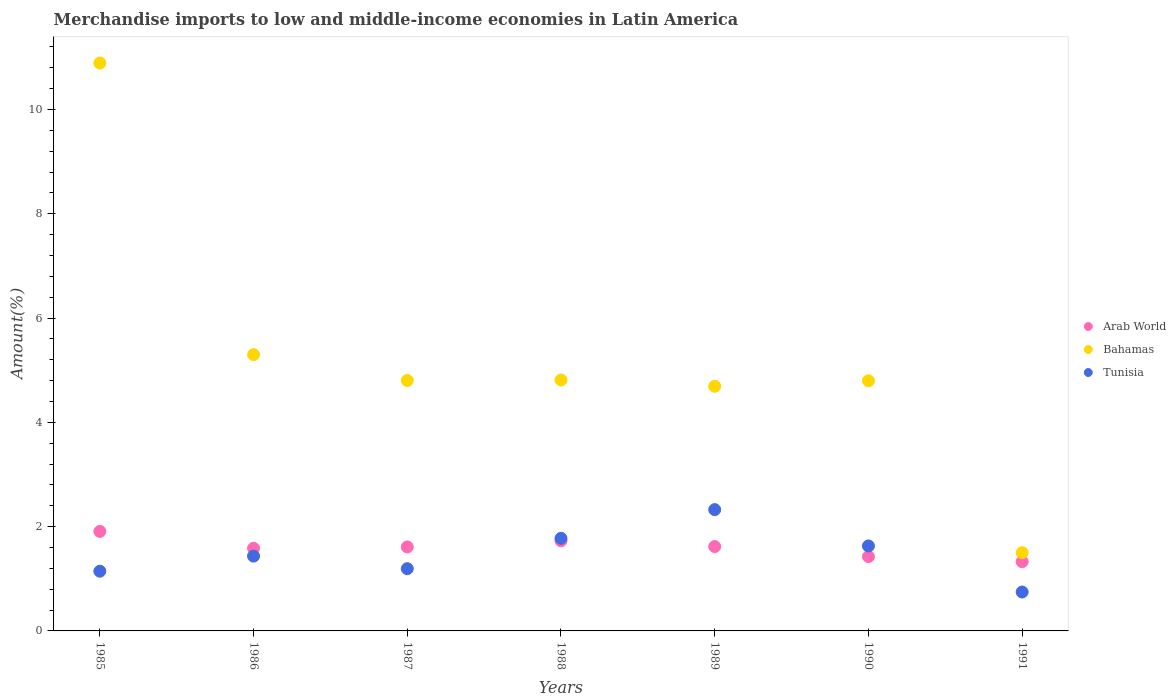Is the number of dotlines equal to the number of legend labels?
Your answer should be very brief. Yes. What is the percentage of amount earned from merchandise imports in Bahamas in 1988?
Your answer should be very brief. 4.81. Across all years, what is the maximum percentage of amount earned from merchandise imports in Bahamas?
Make the answer very short. 10.89. Across all years, what is the minimum percentage of amount earned from merchandise imports in Bahamas?
Provide a succinct answer. 1.5. In which year was the percentage of amount earned from merchandise imports in Arab World maximum?
Ensure brevity in your answer.  1985. In which year was the percentage of amount earned from merchandise imports in Arab World minimum?
Make the answer very short. 1991. What is the total percentage of amount earned from merchandise imports in Arab World in the graph?
Ensure brevity in your answer.  11.2. What is the difference between the percentage of amount earned from merchandise imports in Tunisia in 1985 and that in 1989?
Give a very brief answer. -1.18. What is the difference between the percentage of amount earned from merchandise imports in Tunisia in 1991 and the percentage of amount earned from merchandise imports in Arab World in 1987?
Provide a short and direct response. -0.86. What is the average percentage of amount earned from merchandise imports in Bahamas per year?
Your response must be concise. 5.26. In the year 1991, what is the difference between the percentage of amount earned from merchandise imports in Arab World and percentage of amount earned from merchandise imports in Tunisia?
Give a very brief answer. 0.58. What is the ratio of the percentage of amount earned from merchandise imports in Arab World in 1985 to that in 1990?
Offer a very short reply. 1.34. Is the percentage of amount earned from merchandise imports in Bahamas in 1988 less than that in 1991?
Your answer should be very brief. No. Is the difference between the percentage of amount earned from merchandise imports in Arab World in 1987 and 1989 greater than the difference between the percentage of amount earned from merchandise imports in Tunisia in 1987 and 1989?
Keep it short and to the point. Yes. What is the difference between the highest and the second highest percentage of amount earned from merchandise imports in Tunisia?
Your answer should be very brief. 0.55. What is the difference between the highest and the lowest percentage of amount earned from merchandise imports in Bahamas?
Provide a short and direct response. 9.39. Is the sum of the percentage of amount earned from merchandise imports in Bahamas in 1985 and 1991 greater than the maximum percentage of amount earned from merchandise imports in Tunisia across all years?
Provide a short and direct response. Yes. Is it the case that in every year, the sum of the percentage of amount earned from merchandise imports in Tunisia and percentage of amount earned from merchandise imports in Arab World  is greater than the percentage of amount earned from merchandise imports in Bahamas?
Give a very brief answer. No. Does the percentage of amount earned from merchandise imports in Arab World monotonically increase over the years?
Your response must be concise. No. How many years are there in the graph?
Give a very brief answer. 7. Are the values on the major ticks of Y-axis written in scientific E-notation?
Your answer should be compact. No. Does the graph contain grids?
Your answer should be very brief. No. Where does the legend appear in the graph?
Your answer should be very brief. Center right. How many legend labels are there?
Provide a short and direct response. 3. What is the title of the graph?
Your response must be concise. Merchandise imports to low and middle-income economies in Latin America. What is the label or title of the Y-axis?
Your answer should be very brief. Amount(%). What is the Amount(%) in Arab World in 1985?
Your answer should be very brief. 1.91. What is the Amount(%) of Bahamas in 1985?
Offer a very short reply. 10.89. What is the Amount(%) in Tunisia in 1985?
Ensure brevity in your answer.  1.15. What is the Amount(%) of Arab World in 1986?
Keep it short and to the point. 1.58. What is the Amount(%) of Bahamas in 1986?
Your response must be concise. 5.3. What is the Amount(%) of Tunisia in 1986?
Keep it short and to the point. 1.43. What is the Amount(%) of Arab World in 1987?
Ensure brevity in your answer.  1.61. What is the Amount(%) in Bahamas in 1987?
Offer a very short reply. 4.8. What is the Amount(%) in Tunisia in 1987?
Give a very brief answer. 1.19. What is the Amount(%) in Arab World in 1988?
Provide a short and direct response. 1.73. What is the Amount(%) of Bahamas in 1988?
Your answer should be compact. 4.81. What is the Amount(%) in Tunisia in 1988?
Ensure brevity in your answer.  1.78. What is the Amount(%) in Arab World in 1989?
Make the answer very short. 1.62. What is the Amount(%) in Bahamas in 1989?
Give a very brief answer. 4.69. What is the Amount(%) of Tunisia in 1989?
Your answer should be compact. 2.33. What is the Amount(%) in Arab World in 1990?
Offer a very short reply. 1.43. What is the Amount(%) of Bahamas in 1990?
Offer a terse response. 4.8. What is the Amount(%) of Tunisia in 1990?
Offer a terse response. 1.63. What is the Amount(%) of Arab World in 1991?
Keep it short and to the point. 1.33. What is the Amount(%) of Bahamas in 1991?
Ensure brevity in your answer.  1.5. What is the Amount(%) of Tunisia in 1991?
Offer a terse response. 0.75. Across all years, what is the maximum Amount(%) in Arab World?
Offer a very short reply. 1.91. Across all years, what is the maximum Amount(%) of Bahamas?
Offer a very short reply. 10.89. Across all years, what is the maximum Amount(%) of Tunisia?
Keep it short and to the point. 2.33. Across all years, what is the minimum Amount(%) in Arab World?
Provide a short and direct response. 1.33. Across all years, what is the minimum Amount(%) in Bahamas?
Ensure brevity in your answer.  1.5. Across all years, what is the minimum Amount(%) in Tunisia?
Offer a terse response. 0.75. What is the total Amount(%) of Arab World in the graph?
Your answer should be very brief. 11.2. What is the total Amount(%) of Bahamas in the graph?
Provide a succinct answer. 36.79. What is the total Amount(%) in Tunisia in the graph?
Your answer should be very brief. 10.25. What is the difference between the Amount(%) of Arab World in 1985 and that in 1986?
Provide a short and direct response. 0.32. What is the difference between the Amount(%) in Bahamas in 1985 and that in 1986?
Offer a terse response. 5.59. What is the difference between the Amount(%) in Tunisia in 1985 and that in 1986?
Provide a succinct answer. -0.29. What is the difference between the Amount(%) of Arab World in 1985 and that in 1987?
Offer a very short reply. 0.3. What is the difference between the Amount(%) of Bahamas in 1985 and that in 1987?
Provide a succinct answer. 6.09. What is the difference between the Amount(%) in Tunisia in 1985 and that in 1987?
Provide a succinct answer. -0.05. What is the difference between the Amount(%) of Arab World in 1985 and that in 1988?
Your response must be concise. 0.18. What is the difference between the Amount(%) of Bahamas in 1985 and that in 1988?
Keep it short and to the point. 6.08. What is the difference between the Amount(%) of Tunisia in 1985 and that in 1988?
Offer a terse response. -0.63. What is the difference between the Amount(%) of Arab World in 1985 and that in 1989?
Offer a terse response. 0.29. What is the difference between the Amount(%) of Bahamas in 1985 and that in 1989?
Your answer should be compact. 6.2. What is the difference between the Amount(%) of Tunisia in 1985 and that in 1989?
Give a very brief answer. -1.18. What is the difference between the Amount(%) in Arab World in 1985 and that in 1990?
Your response must be concise. 0.48. What is the difference between the Amount(%) of Bahamas in 1985 and that in 1990?
Give a very brief answer. 6.09. What is the difference between the Amount(%) in Tunisia in 1985 and that in 1990?
Your answer should be very brief. -0.48. What is the difference between the Amount(%) in Arab World in 1985 and that in 1991?
Ensure brevity in your answer.  0.58. What is the difference between the Amount(%) of Bahamas in 1985 and that in 1991?
Your answer should be very brief. 9.39. What is the difference between the Amount(%) in Tunisia in 1985 and that in 1991?
Your response must be concise. 0.4. What is the difference between the Amount(%) of Arab World in 1986 and that in 1987?
Make the answer very short. -0.03. What is the difference between the Amount(%) in Bahamas in 1986 and that in 1987?
Offer a terse response. 0.5. What is the difference between the Amount(%) in Tunisia in 1986 and that in 1987?
Give a very brief answer. 0.24. What is the difference between the Amount(%) in Arab World in 1986 and that in 1988?
Give a very brief answer. -0.14. What is the difference between the Amount(%) of Bahamas in 1986 and that in 1988?
Your answer should be compact. 0.49. What is the difference between the Amount(%) in Tunisia in 1986 and that in 1988?
Give a very brief answer. -0.34. What is the difference between the Amount(%) of Arab World in 1986 and that in 1989?
Make the answer very short. -0.03. What is the difference between the Amount(%) in Bahamas in 1986 and that in 1989?
Provide a succinct answer. 0.61. What is the difference between the Amount(%) in Tunisia in 1986 and that in 1989?
Your answer should be very brief. -0.89. What is the difference between the Amount(%) in Arab World in 1986 and that in 1990?
Make the answer very short. 0.16. What is the difference between the Amount(%) of Bahamas in 1986 and that in 1990?
Your response must be concise. 0.5. What is the difference between the Amount(%) in Tunisia in 1986 and that in 1990?
Ensure brevity in your answer.  -0.19. What is the difference between the Amount(%) of Arab World in 1986 and that in 1991?
Your answer should be very brief. 0.26. What is the difference between the Amount(%) in Bahamas in 1986 and that in 1991?
Provide a short and direct response. 3.8. What is the difference between the Amount(%) of Tunisia in 1986 and that in 1991?
Offer a terse response. 0.69. What is the difference between the Amount(%) in Arab World in 1987 and that in 1988?
Give a very brief answer. -0.12. What is the difference between the Amount(%) in Bahamas in 1987 and that in 1988?
Your answer should be compact. -0.01. What is the difference between the Amount(%) in Tunisia in 1987 and that in 1988?
Your answer should be compact. -0.58. What is the difference between the Amount(%) in Arab World in 1987 and that in 1989?
Provide a short and direct response. -0.01. What is the difference between the Amount(%) in Tunisia in 1987 and that in 1989?
Your answer should be compact. -1.13. What is the difference between the Amount(%) in Arab World in 1987 and that in 1990?
Offer a terse response. 0.18. What is the difference between the Amount(%) of Bahamas in 1987 and that in 1990?
Ensure brevity in your answer.  0.01. What is the difference between the Amount(%) of Tunisia in 1987 and that in 1990?
Give a very brief answer. -0.44. What is the difference between the Amount(%) of Arab World in 1987 and that in 1991?
Your answer should be compact. 0.28. What is the difference between the Amount(%) of Bahamas in 1987 and that in 1991?
Give a very brief answer. 3.3. What is the difference between the Amount(%) in Tunisia in 1987 and that in 1991?
Provide a succinct answer. 0.45. What is the difference between the Amount(%) of Arab World in 1988 and that in 1989?
Provide a succinct answer. 0.11. What is the difference between the Amount(%) of Bahamas in 1988 and that in 1989?
Keep it short and to the point. 0.12. What is the difference between the Amount(%) of Tunisia in 1988 and that in 1989?
Provide a short and direct response. -0.55. What is the difference between the Amount(%) of Arab World in 1988 and that in 1990?
Offer a terse response. 0.3. What is the difference between the Amount(%) in Bahamas in 1988 and that in 1990?
Provide a short and direct response. 0.02. What is the difference between the Amount(%) of Tunisia in 1988 and that in 1990?
Make the answer very short. 0.15. What is the difference between the Amount(%) of Arab World in 1988 and that in 1991?
Offer a very short reply. 0.4. What is the difference between the Amount(%) of Bahamas in 1988 and that in 1991?
Offer a very short reply. 3.31. What is the difference between the Amount(%) of Tunisia in 1988 and that in 1991?
Your answer should be very brief. 1.03. What is the difference between the Amount(%) of Arab World in 1989 and that in 1990?
Your response must be concise. 0.19. What is the difference between the Amount(%) of Bahamas in 1989 and that in 1990?
Ensure brevity in your answer.  -0.11. What is the difference between the Amount(%) in Tunisia in 1989 and that in 1990?
Ensure brevity in your answer.  0.7. What is the difference between the Amount(%) in Arab World in 1989 and that in 1991?
Your answer should be very brief. 0.29. What is the difference between the Amount(%) in Bahamas in 1989 and that in 1991?
Keep it short and to the point. 3.19. What is the difference between the Amount(%) of Tunisia in 1989 and that in 1991?
Offer a very short reply. 1.58. What is the difference between the Amount(%) of Arab World in 1990 and that in 1991?
Your answer should be very brief. 0.1. What is the difference between the Amount(%) of Bahamas in 1990 and that in 1991?
Offer a terse response. 3.3. What is the difference between the Amount(%) in Tunisia in 1990 and that in 1991?
Offer a very short reply. 0.88. What is the difference between the Amount(%) of Arab World in 1985 and the Amount(%) of Bahamas in 1986?
Provide a short and direct response. -3.39. What is the difference between the Amount(%) in Arab World in 1985 and the Amount(%) in Tunisia in 1986?
Provide a short and direct response. 0.47. What is the difference between the Amount(%) in Bahamas in 1985 and the Amount(%) in Tunisia in 1986?
Your response must be concise. 9.46. What is the difference between the Amount(%) in Arab World in 1985 and the Amount(%) in Bahamas in 1987?
Provide a short and direct response. -2.89. What is the difference between the Amount(%) in Arab World in 1985 and the Amount(%) in Tunisia in 1987?
Offer a terse response. 0.71. What is the difference between the Amount(%) in Bahamas in 1985 and the Amount(%) in Tunisia in 1987?
Your answer should be very brief. 9.7. What is the difference between the Amount(%) of Arab World in 1985 and the Amount(%) of Bahamas in 1988?
Offer a very short reply. -2.9. What is the difference between the Amount(%) in Arab World in 1985 and the Amount(%) in Tunisia in 1988?
Make the answer very short. 0.13. What is the difference between the Amount(%) in Bahamas in 1985 and the Amount(%) in Tunisia in 1988?
Give a very brief answer. 9.11. What is the difference between the Amount(%) in Arab World in 1985 and the Amount(%) in Bahamas in 1989?
Offer a very short reply. -2.78. What is the difference between the Amount(%) in Arab World in 1985 and the Amount(%) in Tunisia in 1989?
Keep it short and to the point. -0.42. What is the difference between the Amount(%) of Bahamas in 1985 and the Amount(%) of Tunisia in 1989?
Give a very brief answer. 8.56. What is the difference between the Amount(%) in Arab World in 1985 and the Amount(%) in Bahamas in 1990?
Your answer should be very brief. -2.89. What is the difference between the Amount(%) of Arab World in 1985 and the Amount(%) of Tunisia in 1990?
Make the answer very short. 0.28. What is the difference between the Amount(%) of Bahamas in 1985 and the Amount(%) of Tunisia in 1990?
Make the answer very short. 9.26. What is the difference between the Amount(%) in Arab World in 1985 and the Amount(%) in Bahamas in 1991?
Provide a short and direct response. 0.41. What is the difference between the Amount(%) of Arab World in 1985 and the Amount(%) of Tunisia in 1991?
Your answer should be compact. 1.16. What is the difference between the Amount(%) in Bahamas in 1985 and the Amount(%) in Tunisia in 1991?
Your answer should be compact. 10.14. What is the difference between the Amount(%) of Arab World in 1986 and the Amount(%) of Bahamas in 1987?
Keep it short and to the point. -3.22. What is the difference between the Amount(%) of Arab World in 1986 and the Amount(%) of Tunisia in 1987?
Make the answer very short. 0.39. What is the difference between the Amount(%) of Bahamas in 1986 and the Amount(%) of Tunisia in 1987?
Your response must be concise. 4.1. What is the difference between the Amount(%) in Arab World in 1986 and the Amount(%) in Bahamas in 1988?
Offer a terse response. -3.23. What is the difference between the Amount(%) in Arab World in 1986 and the Amount(%) in Tunisia in 1988?
Keep it short and to the point. -0.19. What is the difference between the Amount(%) of Bahamas in 1986 and the Amount(%) of Tunisia in 1988?
Offer a very short reply. 3.52. What is the difference between the Amount(%) in Arab World in 1986 and the Amount(%) in Bahamas in 1989?
Your answer should be very brief. -3.11. What is the difference between the Amount(%) in Arab World in 1986 and the Amount(%) in Tunisia in 1989?
Ensure brevity in your answer.  -0.74. What is the difference between the Amount(%) in Bahamas in 1986 and the Amount(%) in Tunisia in 1989?
Provide a succinct answer. 2.97. What is the difference between the Amount(%) in Arab World in 1986 and the Amount(%) in Bahamas in 1990?
Offer a very short reply. -3.21. What is the difference between the Amount(%) in Arab World in 1986 and the Amount(%) in Tunisia in 1990?
Ensure brevity in your answer.  -0.04. What is the difference between the Amount(%) of Bahamas in 1986 and the Amount(%) of Tunisia in 1990?
Provide a succinct answer. 3.67. What is the difference between the Amount(%) of Arab World in 1986 and the Amount(%) of Bahamas in 1991?
Your response must be concise. 0.08. What is the difference between the Amount(%) in Arab World in 1986 and the Amount(%) in Tunisia in 1991?
Provide a succinct answer. 0.84. What is the difference between the Amount(%) in Bahamas in 1986 and the Amount(%) in Tunisia in 1991?
Your answer should be compact. 4.55. What is the difference between the Amount(%) of Arab World in 1987 and the Amount(%) of Bahamas in 1988?
Offer a terse response. -3.2. What is the difference between the Amount(%) of Arab World in 1987 and the Amount(%) of Tunisia in 1988?
Offer a very short reply. -0.16. What is the difference between the Amount(%) of Bahamas in 1987 and the Amount(%) of Tunisia in 1988?
Keep it short and to the point. 3.03. What is the difference between the Amount(%) in Arab World in 1987 and the Amount(%) in Bahamas in 1989?
Your response must be concise. -3.08. What is the difference between the Amount(%) of Arab World in 1987 and the Amount(%) of Tunisia in 1989?
Your answer should be compact. -0.72. What is the difference between the Amount(%) in Bahamas in 1987 and the Amount(%) in Tunisia in 1989?
Your answer should be very brief. 2.48. What is the difference between the Amount(%) of Arab World in 1987 and the Amount(%) of Bahamas in 1990?
Your answer should be very brief. -3.19. What is the difference between the Amount(%) in Arab World in 1987 and the Amount(%) in Tunisia in 1990?
Your response must be concise. -0.02. What is the difference between the Amount(%) in Bahamas in 1987 and the Amount(%) in Tunisia in 1990?
Provide a succinct answer. 3.17. What is the difference between the Amount(%) in Arab World in 1987 and the Amount(%) in Bahamas in 1991?
Offer a very short reply. 0.11. What is the difference between the Amount(%) in Arab World in 1987 and the Amount(%) in Tunisia in 1991?
Your answer should be compact. 0.86. What is the difference between the Amount(%) of Bahamas in 1987 and the Amount(%) of Tunisia in 1991?
Provide a succinct answer. 4.06. What is the difference between the Amount(%) in Arab World in 1988 and the Amount(%) in Bahamas in 1989?
Your answer should be very brief. -2.96. What is the difference between the Amount(%) in Arab World in 1988 and the Amount(%) in Tunisia in 1989?
Your answer should be compact. -0.6. What is the difference between the Amount(%) in Bahamas in 1988 and the Amount(%) in Tunisia in 1989?
Offer a terse response. 2.49. What is the difference between the Amount(%) in Arab World in 1988 and the Amount(%) in Bahamas in 1990?
Provide a succinct answer. -3.07. What is the difference between the Amount(%) of Arab World in 1988 and the Amount(%) of Tunisia in 1990?
Your answer should be compact. 0.1. What is the difference between the Amount(%) in Bahamas in 1988 and the Amount(%) in Tunisia in 1990?
Keep it short and to the point. 3.18. What is the difference between the Amount(%) of Arab World in 1988 and the Amount(%) of Bahamas in 1991?
Give a very brief answer. 0.23. What is the difference between the Amount(%) in Arab World in 1988 and the Amount(%) in Tunisia in 1991?
Offer a terse response. 0.98. What is the difference between the Amount(%) in Bahamas in 1988 and the Amount(%) in Tunisia in 1991?
Offer a terse response. 4.07. What is the difference between the Amount(%) in Arab World in 1989 and the Amount(%) in Bahamas in 1990?
Provide a short and direct response. -3.18. What is the difference between the Amount(%) of Arab World in 1989 and the Amount(%) of Tunisia in 1990?
Provide a succinct answer. -0.01. What is the difference between the Amount(%) in Bahamas in 1989 and the Amount(%) in Tunisia in 1990?
Your answer should be compact. 3.06. What is the difference between the Amount(%) in Arab World in 1989 and the Amount(%) in Bahamas in 1991?
Offer a terse response. 0.12. What is the difference between the Amount(%) of Arab World in 1989 and the Amount(%) of Tunisia in 1991?
Provide a succinct answer. 0.87. What is the difference between the Amount(%) of Bahamas in 1989 and the Amount(%) of Tunisia in 1991?
Your answer should be compact. 3.95. What is the difference between the Amount(%) of Arab World in 1990 and the Amount(%) of Bahamas in 1991?
Provide a short and direct response. -0.07. What is the difference between the Amount(%) of Arab World in 1990 and the Amount(%) of Tunisia in 1991?
Provide a short and direct response. 0.68. What is the difference between the Amount(%) in Bahamas in 1990 and the Amount(%) in Tunisia in 1991?
Give a very brief answer. 4.05. What is the average Amount(%) in Arab World per year?
Keep it short and to the point. 1.6. What is the average Amount(%) of Bahamas per year?
Provide a succinct answer. 5.26. What is the average Amount(%) in Tunisia per year?
Your response must be concise. 1.46. In the year 1985, what is the difference between the Amount(%) in Arab World and Amount(%) in Bahamas?
Your response must be concise. -8.98. In the year 1985, what is the difference between the Amount(%) in Arab World and Amount(%) in Tunisia?
Your response must be concise. 0.76. In the year 1985, what is the difference between the Amount(%) of Bahamas and Amount(%) of Tunisia?
Keep it short and to the point. 9.75. In the year 1986, what is the difference between the Amount(%) in Arab World and Amount(%) in Bahamas?
Your answer should be compact. -3.71. In the year 1986, what is the difference between the Amount(%) of Arab World and Amount(%) of Tunisia?
Offer a terse response. 0.15. In the year 1986, what is the difference between the Amount(%) of Bahamas and Amount(%) of Tunisia?
Provide a short and direct response. 3.86. In the year 1987, what is the difference between the Amount(%) of Arab World and Amount(%) of Bahamas?
Your answer should be compact. -3.19. In the year 1987, what is the difference between the Amount(%) in Arab World and Amount(%) in Tunisia?
Ensure brevity in your answer.  0.42. In the year 1987, what is the difference between the Amount(%) in Bahamas and Amount(%) in Tunisia?
Your response must be concise. 3.61. In the year 1988, what is the difference between the Amount(%) of Arab World and Amount(%) of Bahamas?
Give a very brief answer. -3.09. In the year 1988, what is the difference between the Amount(%) in Arab World and Amount(%) in Tunisia?
Your response must be concise. -0.05. In the year 1988, what is the difference between the Amount(%) of Bahamas and Amount(%) of Tunisia?
Provide a succinct answer. 3.04. In the year 1989, what is the difference between the Amount(%) of Arab World and Amount(%) of Bahamas?
Provide a succinct answer. -3.07. In the year 1989, what is the difference between the Amount(%) in Arab World and Amount(%) in Tunisia?
Offer a very short reply. -0.71. In the year 1989, what is the difference between the Amount(%) in Bahamas and Amount(%) in Tunisia?
Offer a very short reply. 2.37. In the year 1990, what is the difference between the Amount(%) of Arab World and Amount(%) of Bahamas?
Ensure brevity in your answer.  -3.37. In the year 1990, what is the difference between the Amount(%) of Arab World and Amount(%) of Tunisia?
Offer a terse response. -0.2. In the year 1990, what is the difference between the Amount(%) in Bahamas and Amount(%) in Tunisia?
Provide a short and direct response. 3.17. In the year 1991, what is the difference between the Amount(%) of Arab World and Amount(%) of Bahamas?
Provide a short and direct response. -0.17. In the year 1991, what is the difference between the Amount(%) in Arab World and Amount(%) in Tunisia?
Offer a very short reply. 0.58. In the year 1991, what is the difference between the Amount(%) of Bahamas and Amount(%) of Tunisia?
Offer a very short reply. 0.75. What is the ratio of the Amount(%) of Arab World in 1985 to that in 1986?
Provide a short and direct response. 1.2. What is the ratio of the Amount(%) of Bahamas in 1985 to that in 1986?
Provide a short and direct response. 2.06. What is the ratio of the Amount(%) of Tunisia in 1985 to that in 1986?
Keep it short and to the point. 0.8. What is the ratio of the Amount(%) in Arab World in 1985 to that in 1987?
Make the answer very short. 1.18. What is the ratio of the Amount(%) in Bahamas in 1985 to that in 1987?
Your answer should be very brief. 2.27. What is the ratio of the Amount(%) of Tunisia in 1985 to that in 1987?
Give a very brief answer. 0.96. What is the ratio of the Amount(%) in Arab World in 1985 to that in 1988?
Provide a succinct answer. 1.11. What is the ratio of the Amount(%) in Bahamas in 1985 to that in 1988?
Provide a succinct answer. 2.26. What is the ratio of the Amount(%) in Tunisia in 1985 to that in 1988?
Offer a very short reply. 0.65. What is the ratio of the Amount(%) in Arab World in 1985 to that in 1989?
Make the answer very short. 1.18. What is the ratio of the Amount(%) in Bahamas in 1985 to that in 1989?
Your response must be concise. 2.32. What is the ratio of the Amount(%) in Tunisia in 1985 to that in 1989?
Provide a succinct answer. 0.49. What is the ratio of the Amount(%) in Arab World in 1985 to that in 1990?
Offer a terse response. 1.34. What is the ratio of the Amount(%) of Bahamas in 1985 to that in 1990?
Your answer should be compact. 2.27. What is the ratio of the Amount(%) of Tunisia in 1985 to that in 1990?
Give a very brief answer. 0.7. What is the ratio of the Amount(%) in Arab World in 1985 to that in 1991?
Give a very brief answer. 1.44. What is the ratio of the Amount(%) in Bahamas in 1985 to that in 1991?
Make the answer very short. 7.26. What is the ratio of the Amount(%) in Tunisia in 1985 to that in 1991?
Your answer should be compact. 1.53. What is the ratio of the Amount(%) of Arab World in 1986 to that in 1987?
Keep it short and to the point. 0.98. What is the ratio of the Amount(%) of Bahamas in 1986 to that in 1987?
Provide a short and direct response. 1.1. What is the ratio of the Amount(%) of Tunisia in 1986 to that in 1987?
Your response must be concise. 1.2. What is the ratio of the Amount(%) of Arab World in 1986 to that in 1988?
Keep it short and to the point. 0.92. What is the ratio of the Amount(%) of Bahamas in 1986 to that in 1988?
Offer a terse response. 1.1. What is the ratio of the Amount(%) in Tunisia in 1986 to that in 1988?
Keep it short and to the point. 0.81. What is the ratio of the Amount(%) of Arab World in 1986 to that in 1989?
Your answer should be very brief. 0.98. What is the ratio of the Amount(%) of Bahamas in 1986 to that in 1989?
Your response must be concise. 1.13. What is the ratio of the Amount(%) of Tunisia in 1986 to that in 1989?
Offer a very short reply. 0.62. What is the ratio of the Amount(%) of Arab World in 1986 to that in 1990?
Keep it short and to the point. 1.11. What is the ratio of the Amount(%) of Bahamas in 1986 to that in 1990?
Offer a very short reply. 1.1. What is the ratio of the Amount(%) in Tunisia in 1986 to that in 1990?
Keep it short and to the point. 0.88. What is the ratio of the Amount(%) of Arab World in 1986 to that in 1991?
Keep it short and to the point. 1.19. What is the ratio of the Amount(%) in Bahamas in 1986 to that in 1991?
Give a very brief answer. 3.53. What is the ratio of the Amount(%) in Tunisia in 1986 to that in 1991?
Provide a short and direct response. 1.92. What is the ratio of the Amount(%) in Arab World in 1987 to that in 1988?
Your response must be concise. 0.93. What is the ratio of the Amount(%) in Tunisia in 1987 to that in 1988?
Provide a succinct answer. 0.67. What is the ratio of the Amount(%) of Bahamas in 1987 to that in 1989?
Give a very brief answer. 1.02. What is the ratio of the Amount(%) in Tunisia in 1987 to that in 1989?
Offer a terse response. 0.51. What is the ratio of the Amount(%) of Arab World in 1987 to that in 1990?
Give a very brief answer. 1.13. What is the ratio of the Amount(%) in Tunisia in 1987 to that in 1990?
Your answer should be compact. 0.73. What is the ratio of the Amount(%) in Arab World in 1987 to that in 1991?
Offer a very short reply. 1.21. What is the ratio of the Amount(%) of Bahamas in 1987 to that in 1991?
Ensure brevity in your answer.  3.2. What is the ratio of the Amount(%) of Tunisia in 1987 to that in 1991?
Offer a very short reply. 1.6. What is the ratio of the Amount(%) of Arab World in 1988 to that in 1989?
Give a very brief answer. 1.07. What is the ratio of the Amount(%) of Bahamas in 1988 to that in 1989?
Offer a terse response. 1.03. What is the ratio of the Amount(%) of Tunisia in 1988 to that in 1989?
Offer a very short reply. 0.76. What is the ratio of the Amount(%) of Arab World in 1988 to that in 1990?
Your answer should be very brief. 1.21. What is the ratio of the Amount(%) of Tunisia in 1988 to that in 1990?
Make the answer very short. 1.09. What is the ratio of the Amount(%) of Arab World in 1988 to that in 1991?
Offer a terse response. 1.3. What is the ratio of the Amount(%) in Bahamas in 1988 to that in 1991?
Your response must be concise. 3.21. What is the ratio of the Amount(%) of Tunisia in 1988 to that in 1991?
Ensure brevity in your answer.  2.38. What is the ratio of the Amount(%) of Arab World in 1989 to that in 1990?
Offer a very short reply. 1.13. What is the ratio of the Amount(%) in Bahamas in 1989 to that in 1990?
Offer a terse response. 0.98. What is the ratio of the Amount(%) in Tunisia in 1989 to that in 1990?
Give a very brief answer. 1.43. What is the ratio of the Amount(%) in Arab World in 1989 to that in 1991?
Offer a terse response. 1.22. What is the ratio of the Amount(%) of Bahamas in 1989 to that in 1991?
Your answer should be very brief. 3.13. What is the ratio of the Amount(%) in Tunisia in 1989 to that in 1991?
Provide a succinct answer. 3.12. What is the ratio of the Amount(%) in Arab World in 1990 to that in 1991?
Your answer should be very brief. 1.07. What is the ratio of the Amount(%) in Bahamas in 1990 to that in 1991?
Offer a very short reply. 3.2. What is the ratio of the Amount(%) in Tunisia in 1990 to that in 1991?
Your response must be concise. 2.18. What is the difference between the highest and the second highest Amount(%) of Arab World?
Ensure brevity in your answer.  0.18. What is the difference between the highest and the second highest Amount(%) of Bahamas?
Provide a succinct answer. 5.59. What is the difference between the highest and the second highest Amount(%) of Tunisia?
Your answer should be very brief. 0.55. What is the difference between the highest and the lowest Amount(%) in Arab World?
Provide a succinct answer. 0.58. What is the difference between the highest and the lowest Amount(%) in Bahamas?
Offer a terse response. 9.39. What is the difference between the highest and the lowest Amount(%) of Tunisia?
Offer a terse response. 1.58. 